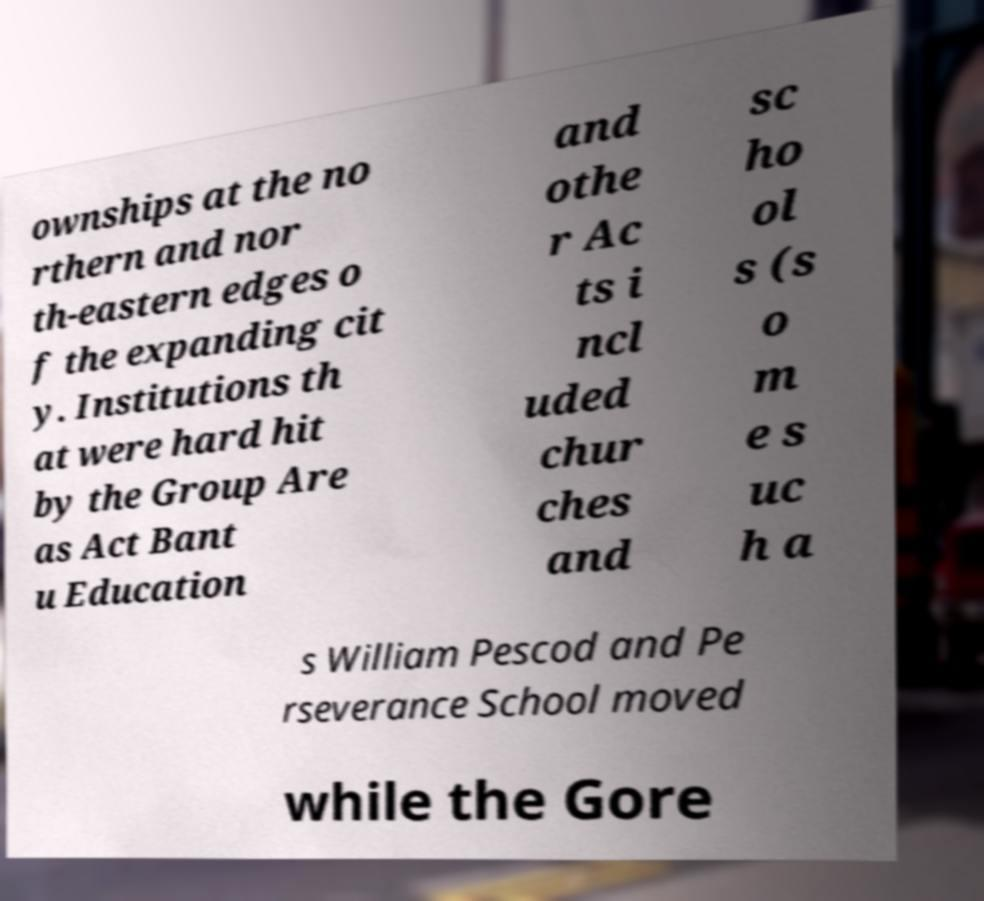Please read and relay the text visible in this image. What does it say? ownships at the no rthern and nor th-eastern edges o f the expanding cit y. Institutions th at were hard hit by the Group Are as Act Bant u Education and othe r Ac ts i ncl uded chur ches and sc ho ol s (s o m e s uc h a s William Pescod and Pe rseverance School moved while the Gore 